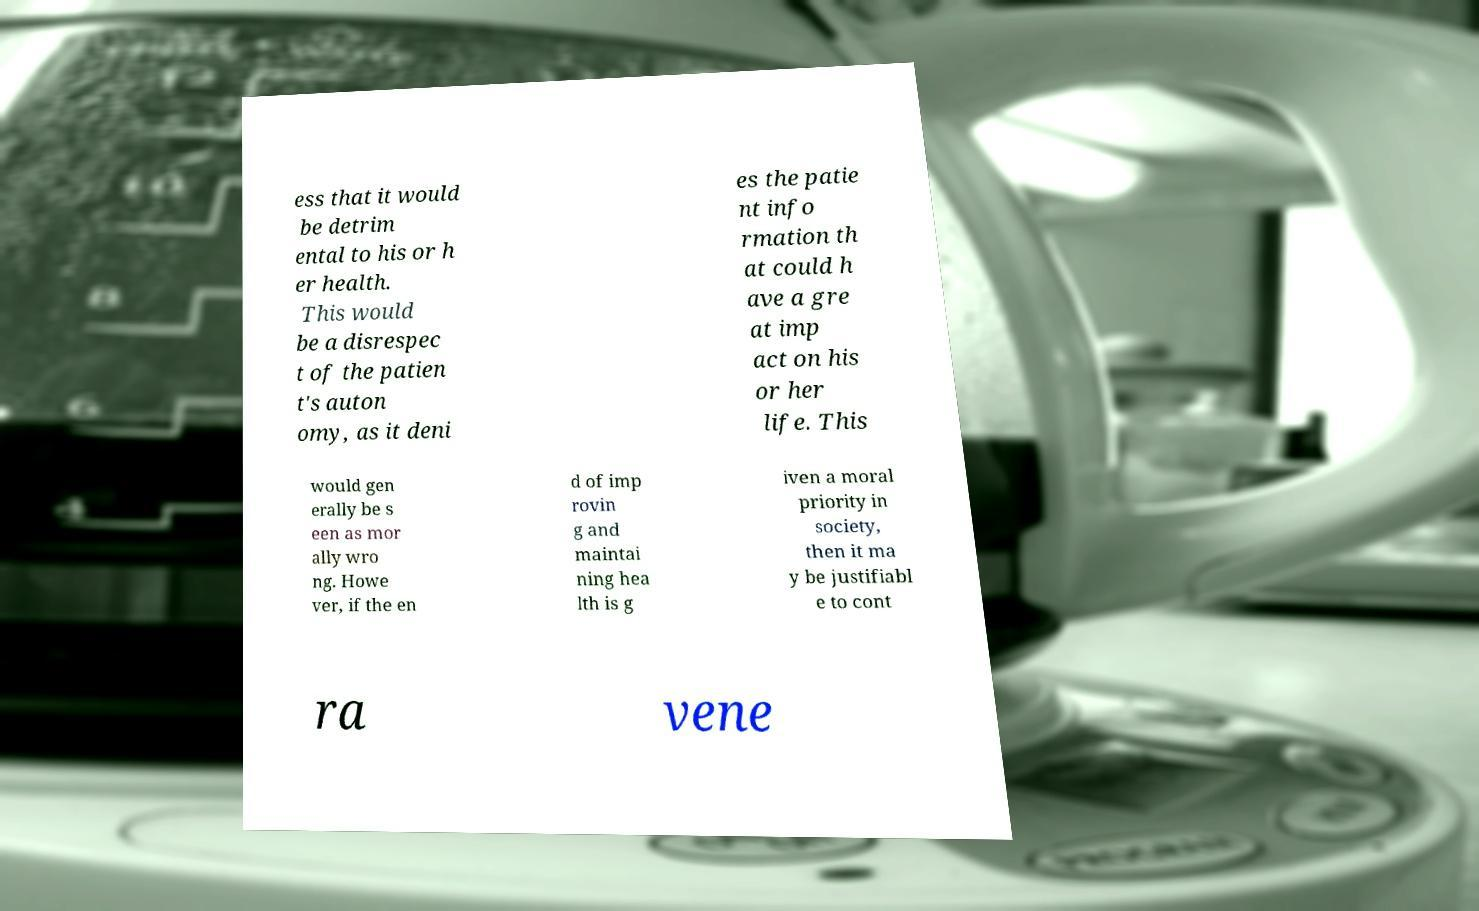Please read and relay the text visible in this image. What does it say? ess that it would be detrim ental to his or h er health. This would be a disrespec t of the patien t's auton omy, as it deni es the patie nt info rmation th at could h ave a gre at imp act on his or her life. This would gen erally be s een as mor ally wro ng. Howe ver, if the en d of imp rovin g and maintai ning hea lth is g iven a moral priority in society, then it ma y be justifiabl e to cont ra vene 